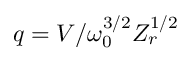Convert formula to latex. <formula><loc_0><loc_0><loc_500><loc_500>q = V / \omega _ { 0 } ^ { 3 / 2 } Z _ { r } ^ { 1 / 2 }</formula> 